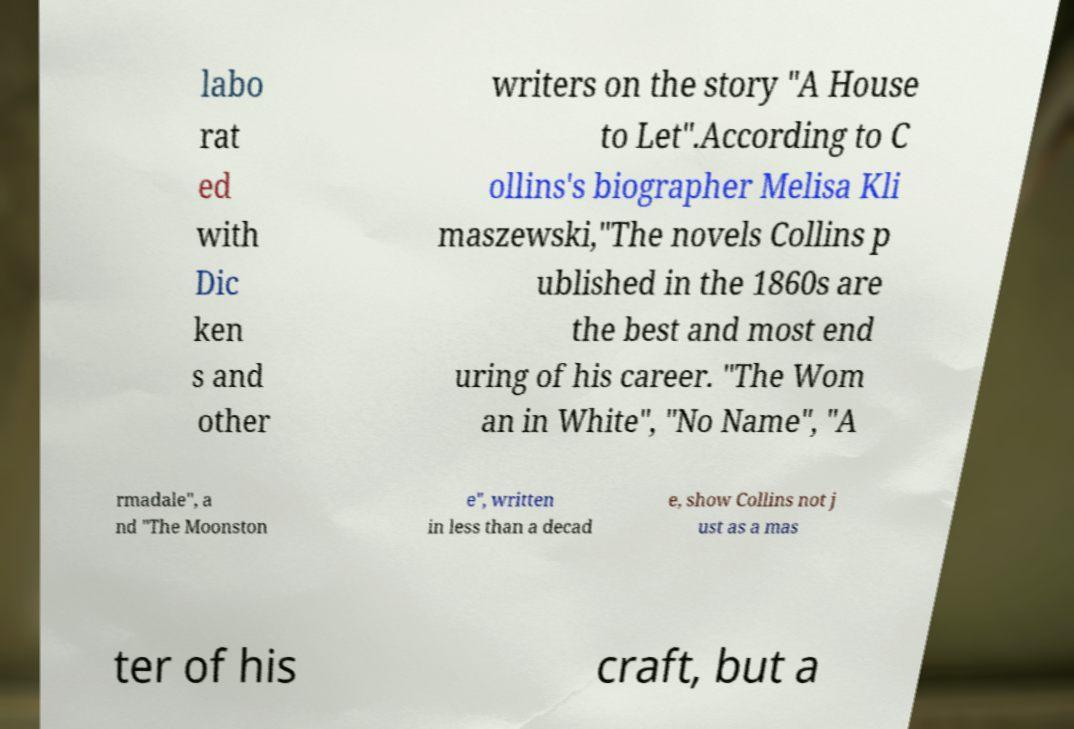I need the written content from this picture converted into text. Can you do that? labo rat ed with Dic ken s and other writers on the story "A House to Let".According to C ollins's biographer Melisa Kli maszewski,"The novels Collins p ublished in the 1860s are the best and most end uring of his career. "The Wom an in White", "No Name", "A rmadale", a nd "The Moonston e", written in less than a decad e, show Collins not j ust as a mas ter of his craft, but a 